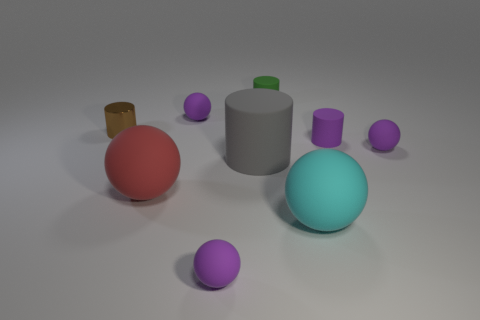Subtract all small metallic cylinders. How many cylinders are left? 3 Subtract all purple cubes. How many purple balls are left? 3 Subtract all brown cylinders. How many cylinders are left? 3 Subtract 1 cylinders. How many cylinders are left? 3 Subtract 0 green spheres. How many objects are left? 9 Subtract all cylinders. How many objects are left? 5 Subtract all blue cylinders. Subtract all yellow balls. How many cylinders are left? 4 Subtract all cyan spheres. Subtract all small brown cylinders. How many objects are left? 7 Add 1 large rubber cylinders. How many large rubber cylinders are left? 2 Add 7 big objects. How many big objects exist? 10 